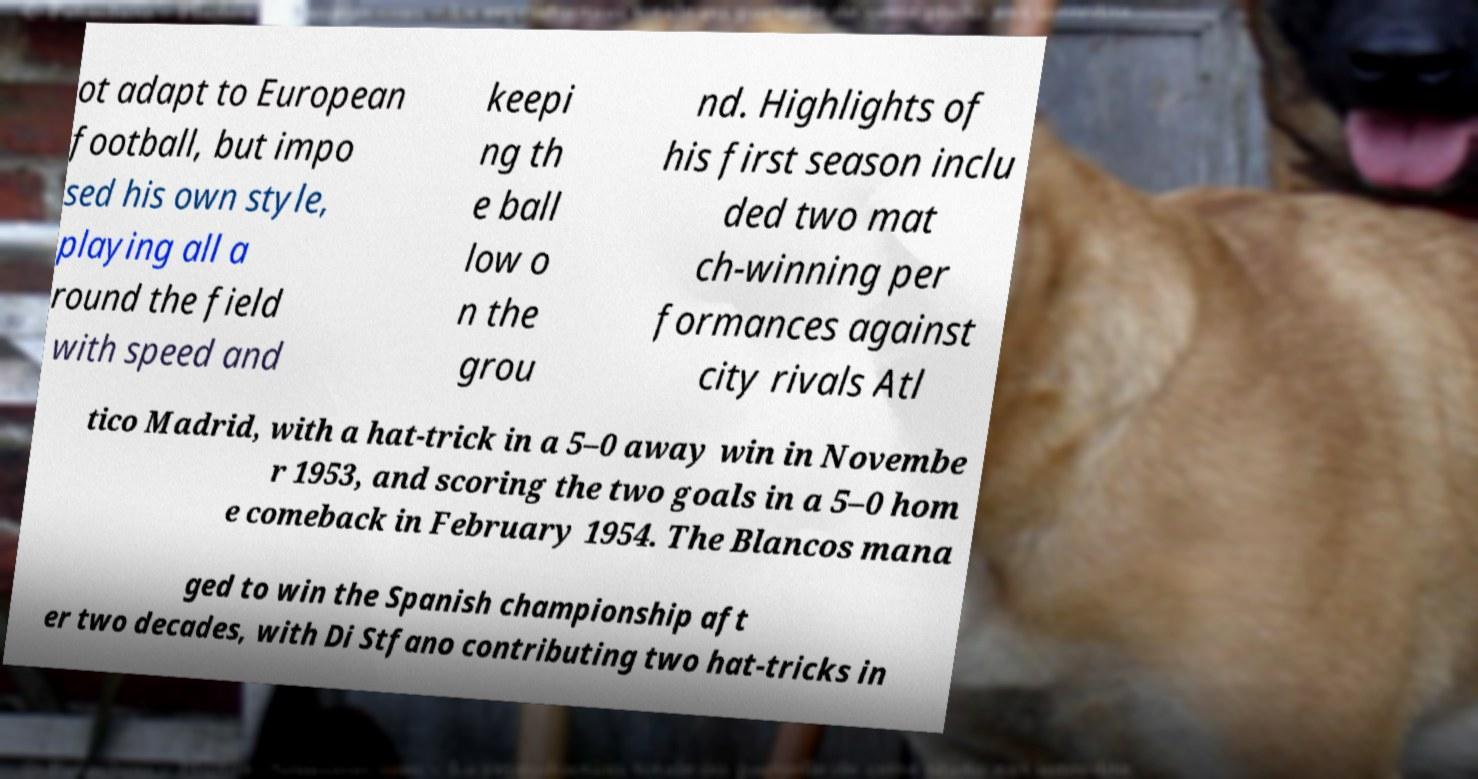I need the written content from this picture converted into text. Can you do that? ot adapt to European football, but impo sed his own style, playing all a round the field with speed and keepi ng th e ball low o n the grou nd. Highlights of his first season inclu ded two mat ch-winning per formances against city rivals Atl tico Madrid, with a hat-trick in a 5–0 away win in Novembe r 1953, and scoring the two goals in a 5–0 hom e comeback in February 1954. The Blancos mana ged to win the Spanish championship aft er two decades, with Di Stfano contributing two hat-tricks in 